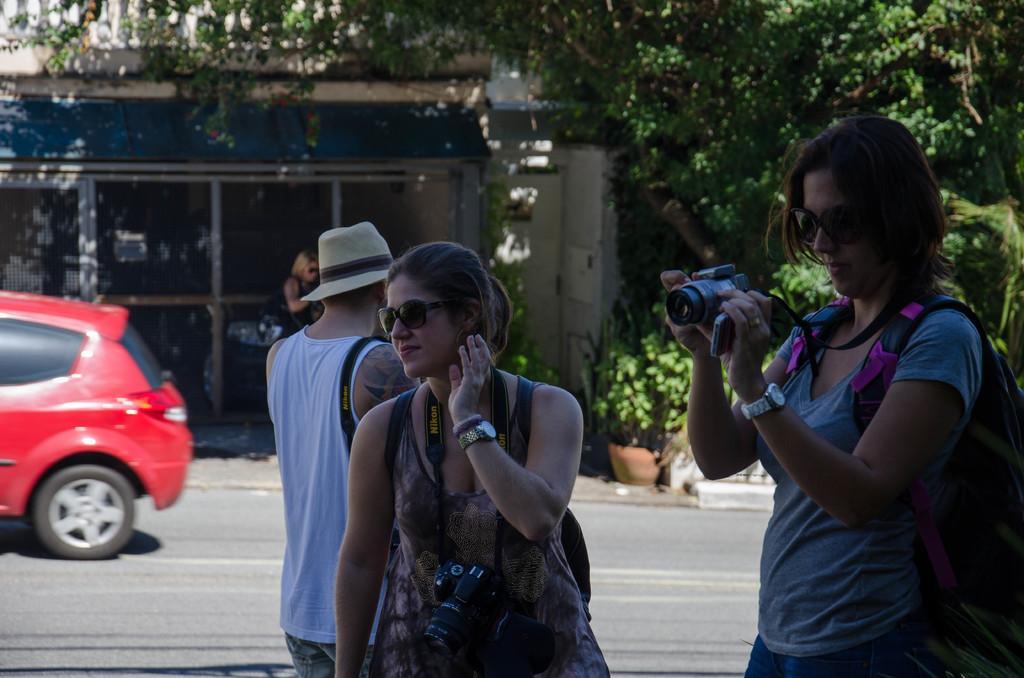Please provide a concise description of this image. In the foreground I can see four persons on the road and a woman is holding a camera in hand. In the background I can see trees, building, houseplants and a car on the road. This image is taken during a day. 